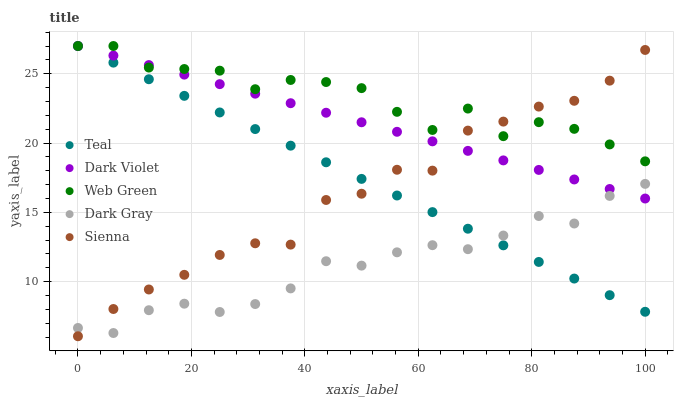Does Dark Gray have the minimum area under the curve?
Answer yes or no. Yes. Does Web Green have the maximum area under the curve?
Answer yes or no. Yes. Does Sienna have the minimum area under the curve?
Answer yes or no. No. Does Sienna have the maximum area under the curve?
Answer yes or no. No. Is Teal the smoothest?
Answer yes or no. Yes. Is Web Green the roughest?
Answer yes or no. Yes. Is Sienna the smoothest?
Answer yes or no. No. Is Sienna the roughest?
Answer yes or no. No. Does Sienna have the lowest value?
Answer yes or no. Yes. Does Web Green have the lowest value?
Answer yes or no. No. Does Teal have the highest value?
Answer yes or no. Yes. Does Sienna have the highest value?
Answer yes or no. No. Is Dark Gray less than Web Green?
Answer yes or no. Yes. Is Web Green greater than Dark Gray?
Answer yes or no. Yes. Does Dark Gray intersect Sienna?
Answer yes or no. Yes. Is Dark Gray less than Sienna?
Answer yes or no. No. Is Dark Gray greater than Sienna?
Answer yes or no. No. Does Dark Gray intersect Web Green?
Answer yes or no. No. 